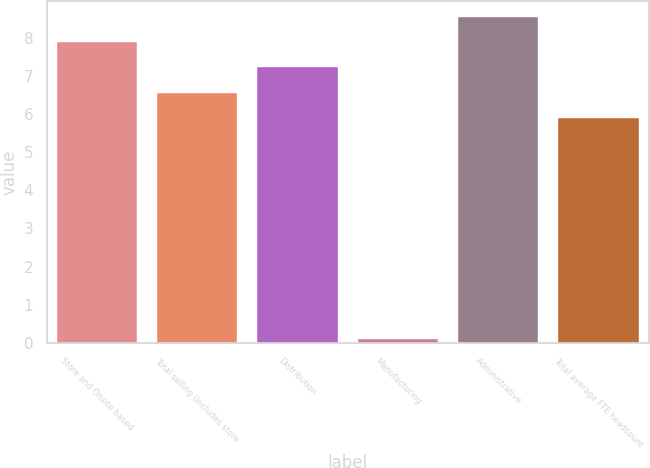Convert chart. <chart><loc_0><loc_0><loc_500><loc_500><bar_chart><fcel>Store and Onsite based<fcel>Total selling (includes store<fcel>Distribution<fcel>Manufacturing<fcel>Administrative<fcel>Total average FTE headcount<nl><fcel>7.88<fcel>6.56<fcel>7.22<fcel>0.1<fcel>8.54<fcel>5.9<nl></chart> 